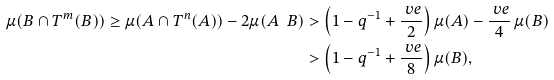Convert formula to latex. <formula><loc_0><loc_0><loc_500><loc_500>\mu ( B \cap T ^ { m } ( B ) ) \geq \mu ( A \cap T ^ { n } ( A ) ) - 2 \mu ( A \ B ) & > \left ( 1 - q ^ { - 1 } + \frac { \ v e } { 2 } \right ) \mu ( A ) - \frac { \ v e } { 4 } \, \mu ( B ) \\ & > \left ( 1 - q ^ { - 1 } + \frac { \ v e } { 8 } \right ) \mu ( B ) ,</formula> 